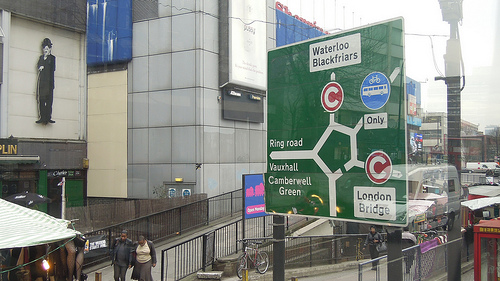<image>
Is there a man under the sign? No. The man is not positioned under the sign. The vertical relationship between these objects is different. 